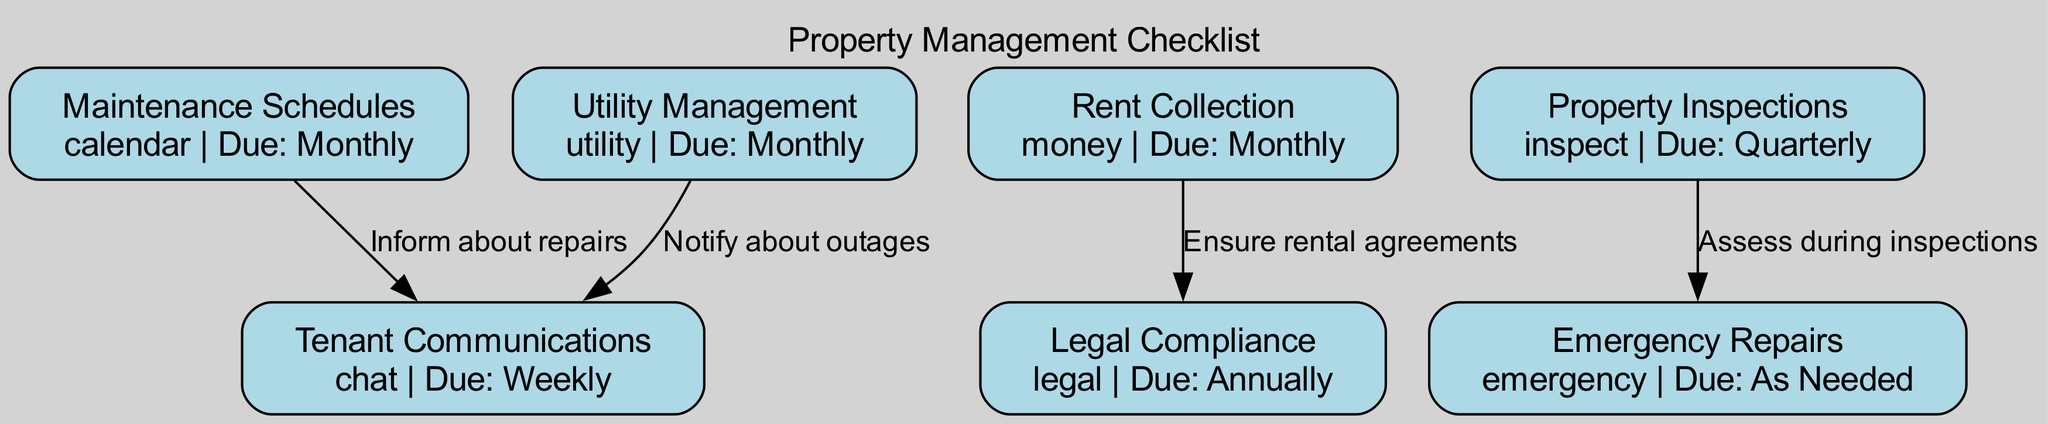What is the due date for maintenance schedules? The diagram states the due date for maintenance schedules is "Monthly," which is directly indicated next to the node labeled "Maintenance Schedules."
Answer: Monthly How many edges are there in the diagram? Counting the connections (edges) between the nodes, there are four edges connecting different tasks. This includes any relationship mentioned in the edges summary.
Answer: 4 Which task is associated with tenant communications? Tenant communications is linked to two tasks: "Maintenance Schedules" (informing about repairs) and "Utility Management" (notifying about outages). This is evidenced by the connections drawn from "Tenant Communications" to these nodes.
Answer: Tenant Communications What is the icon for emergency repairs? The icon associated with emergency repairs is "emergency," which is depicted next to the node labeled "Emergency Repairs" in the diagram.
Answer: Emergency What is the frequency of property inspections? The diagram specifies that property inspections should be conducted "Quarterly," which is shown as the due date next to the "Property Inspections" node.
Answer: Quarterly Which task must be completed before ensuring legal compliance? The task that must be completed before ensuring legal compliance is "Rent Collection," as indicated by the directed edge which describes that rental agreements must be ensured from rent collection.
Answer: Rent Collection What task is performed "As Needed"? According to the diagram, the task that is categorized to be performed "As Needed" is "Emergency Repairs," as indicated next to the corresponding node.
Answer: Emergency Repairs How does utility management relate to tenant communications? Utility management notifies tenants about outages, which is explicitly indicated by the edge connecting "Utility Management" to "Tenant Communications" in the diagram.
Answer: Notify about outages 